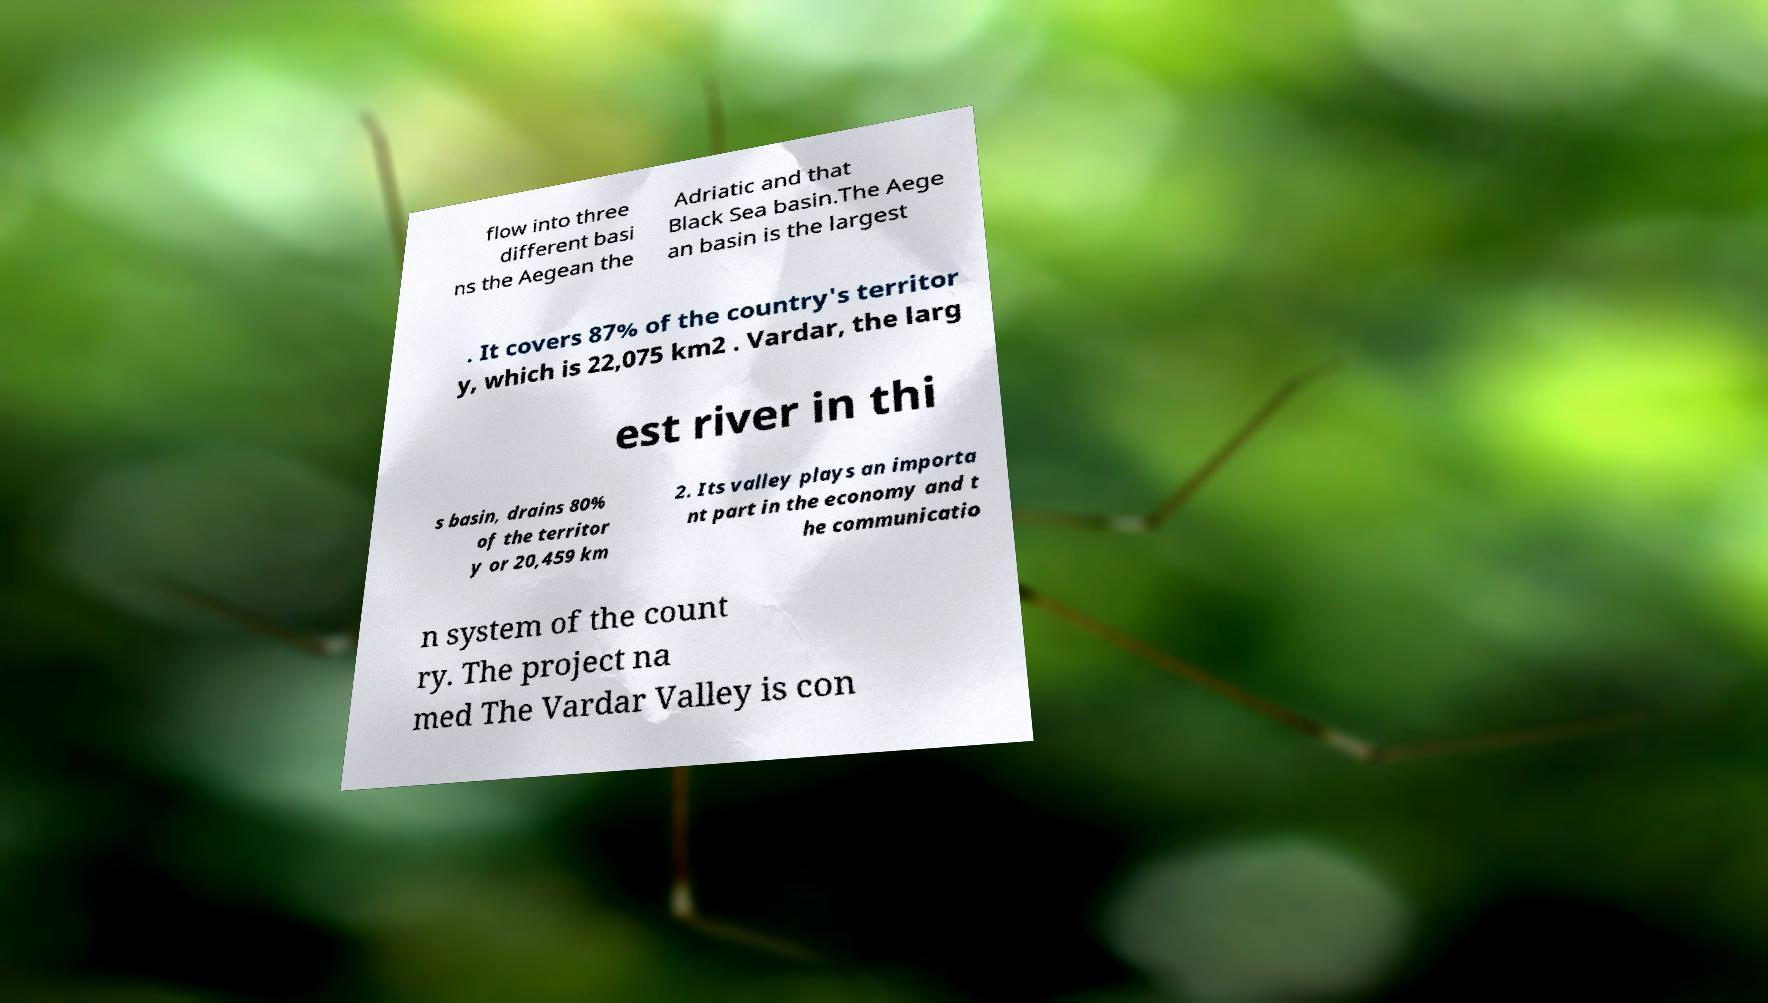What messages or text are displayed in this image? I need them in a readable, typed format. flow into three different basi ns the Aegean the Adriatic and that Black Sea basin.The Aege an basin is the largest . It covers 87% of the country's territor y, which is 22,075 km2 . Vardar, the larg est river in thi s basin, drains 80% of the territor y or 20,459 km 2. Its valley plays an importa nt part in the economy and t he communicatio n system of the count ry. The project na med The Vardar Valley is con 